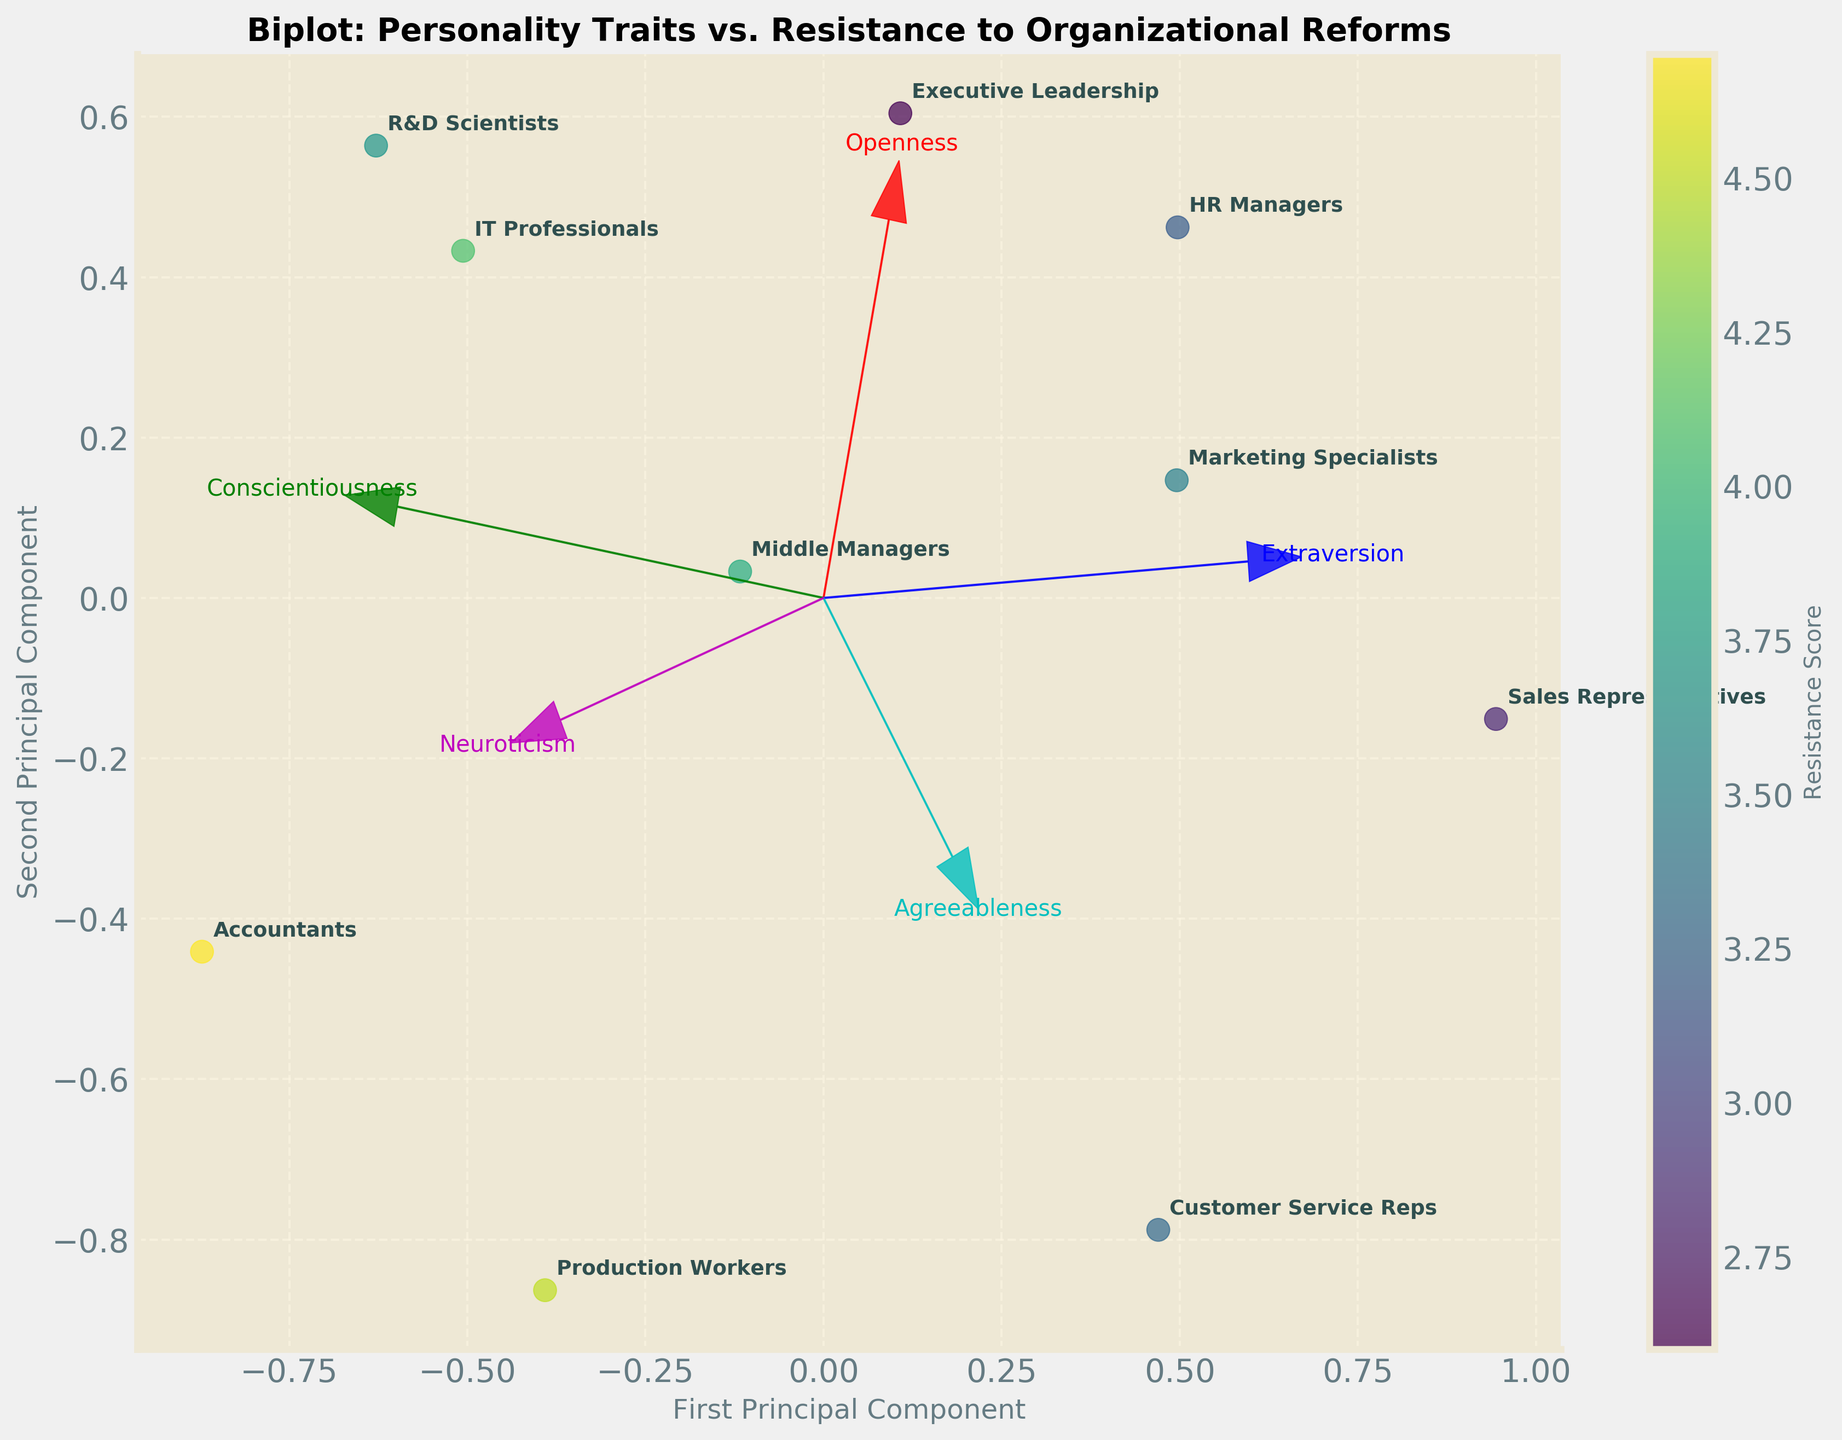What is the title of the figure? The title of the figure is prominently displayed at the top. It reads "Biplot: Personality Traits vs. Resistance to Organizational Reforms."
Answer: Biplot: Personality Traits vs. Resistance to Organizational Reforms How many data points are there in the figure? There are labels for each data point corresponding to different professional roles, which are 10 in total: HR Managers, IT Professionals, Sales Representatives, Accountants, Marketing Specialists, Middle Managers, Executive Leadership, Customer Service Reps, R&D Scientists, and Production Workers.
Answer: 10 Which professional role has the highest resistance score? To identify the professional role with the highest resistance score, you need to observe the color gradient in the scatter plot. The color scale shows that the darker (more intense) colors represent higher scores. "Accountants" appear to have the darkest color, indicating the highest resistance score.
Answer: Accountants Which axis represents the First Principal Component? The axis labels are clearly marked. The x-axis is labeled as "First Principal Component."
Answer: x-axis Which trait has the longest vector, indicating the strongest influence on the first and second principal components? The lengths of the feature vectors (arrows) indicate their influence. The longest vector belongs to "Openness," suggesting it has the strongest influence on the principal components.
Answer: Openness Which professional role has both high Extraversion and high Conscientiousness scores, as indicated by their direction on the biplot? To find this, you look for a data point aligned with the arrows representing "Extraversion" and "Conscientiousness." "Executive Leadership" aligns well with both vectors, suggesting high scores in these traits.
Answer: Executive Leadership Which two professional roles have negative values for Openness? The "Openness" vector points to the right. Professional roles positioned opposite to this direction on the biplot will have negative values. "Accountants" and "Production Workers" are in the opposite direction, indicating negative values for Openness.
Answer: Accountants and Production Workers Which professional role is closest to the origin (0,0) of the plot? The closest data point to the origin indicates a profile with scores close to the average. "Middle Managers" is the point nearest the origin.
Answer: Middle Managers Compare the resistance scores of IT Professionals and Sales Representatives. Which is higher? To determine this, observe the color of the points representing "IT Professionals" and "Sales Representatives." IT Professionals have a slightly higher resistance score (darker color) than Sales Representatives.
Answer: IT Professionals What can you deduce about the relationship between Neuroticism and resistance to reforms? The "Neuroticism" vector points towards higher resistance scores, indicating a positive correlation. Professional roles with higher Neuroticism (positions aligned with the "Neuroticism" vector) tend to have higher resistance scores.
Answer: Positive correlation 